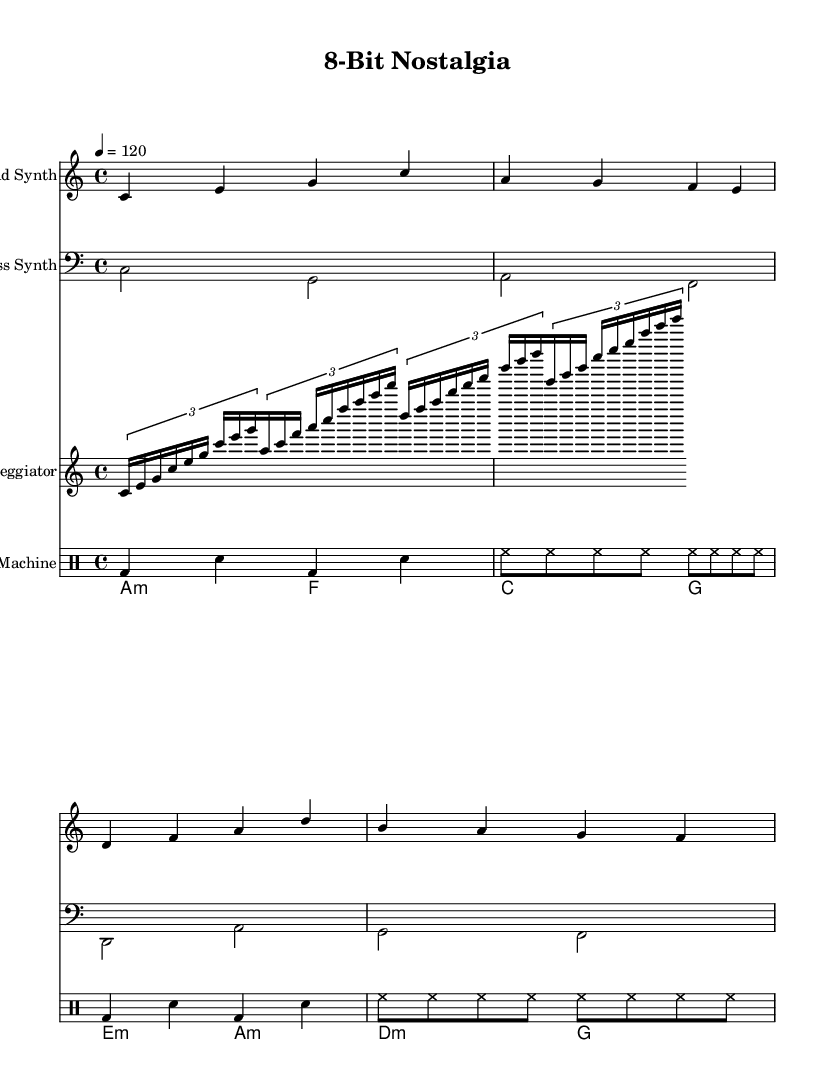What is the key signature of this music? The key signature is indicated at the beginning of the score. It shows that there are no sharps or flats, which means it is in C major.
Answer: C major What is the time signature of this music? The time signature is represented by the numbers at the beginning of the score. It shows that there are four beats per measure, thus indicating a 4/4 time signature.
Answer: 4/4 What is the tempo marking for this piece? The tempo marking is indicated with "4 = 120" at the beginning, which means the metronome should be set to play four beats in one minute at a speed of 120 beats per minute.
Answer: 120 How many measures are there in the lead synth part? By counting the segments of music in the lead synth staff, we find there are four measures in total.
Answer: 4 Which voice plays the arpeggiator? The arpeggiator is noted under the voice three designation in the score, indicating that it is played as the third voice in the arrangement.
Answer: Voice Three What type of chords are used in the bridge section? The chords in the bridge section are labeled with a lowercase 'm', indicating that they are minor chords, such as A minor and E minor.
Answer: Minor How is the drum machine rhythm structured? The rhythm for the drum machine is structured using a combination of bass drums (bd), snare drums (sn), and hi-hat (hh) patterns, as indicated in the drum notation.
Answer: Bass and Snare 